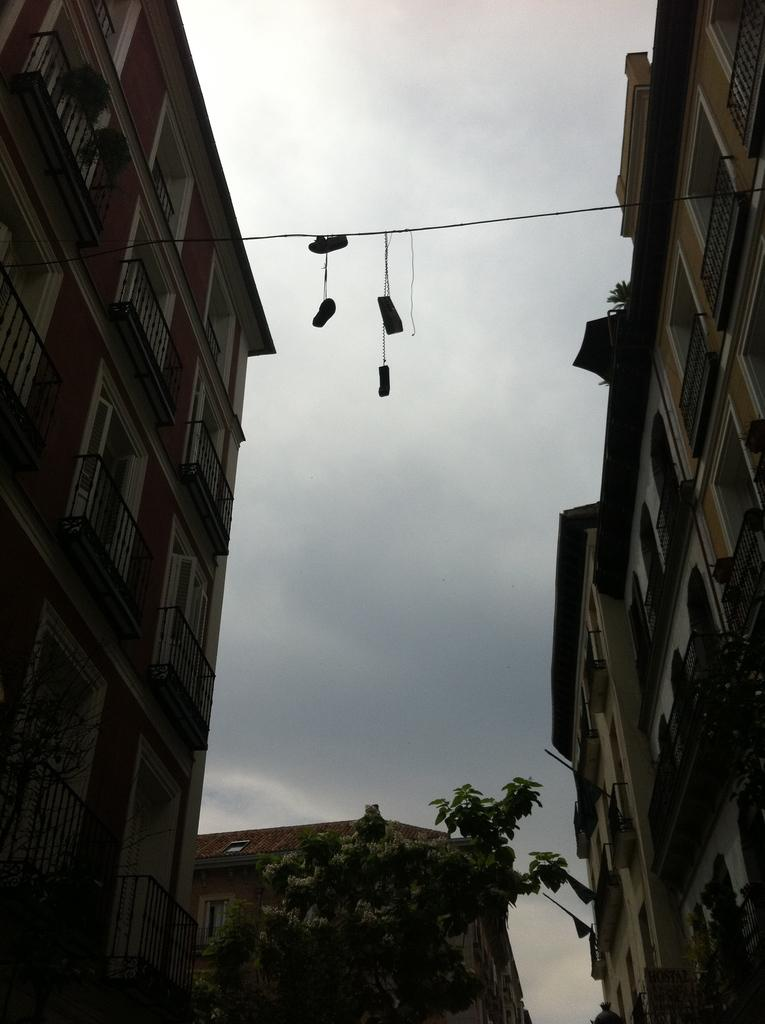What type of structures can be seen in the image? There are buildings in the image. What natural element is present in the image? There is a tree in the image. What man-made object can be seen in the image? There is a cable in the image. Can you describe any other objects in the image? There are other objects in the image, but their specific details are not mentioned in the provided facts. What is visible in the background of the image? The sky is visible in the background of the image. What type of leg injury is visible on the tree in the image? There is no mention of a leg injury or any type of injury on the tree in the image. What kind of disease is affecting the buildings in the image? There is no mention of any disease affecting the buildings in the image. 